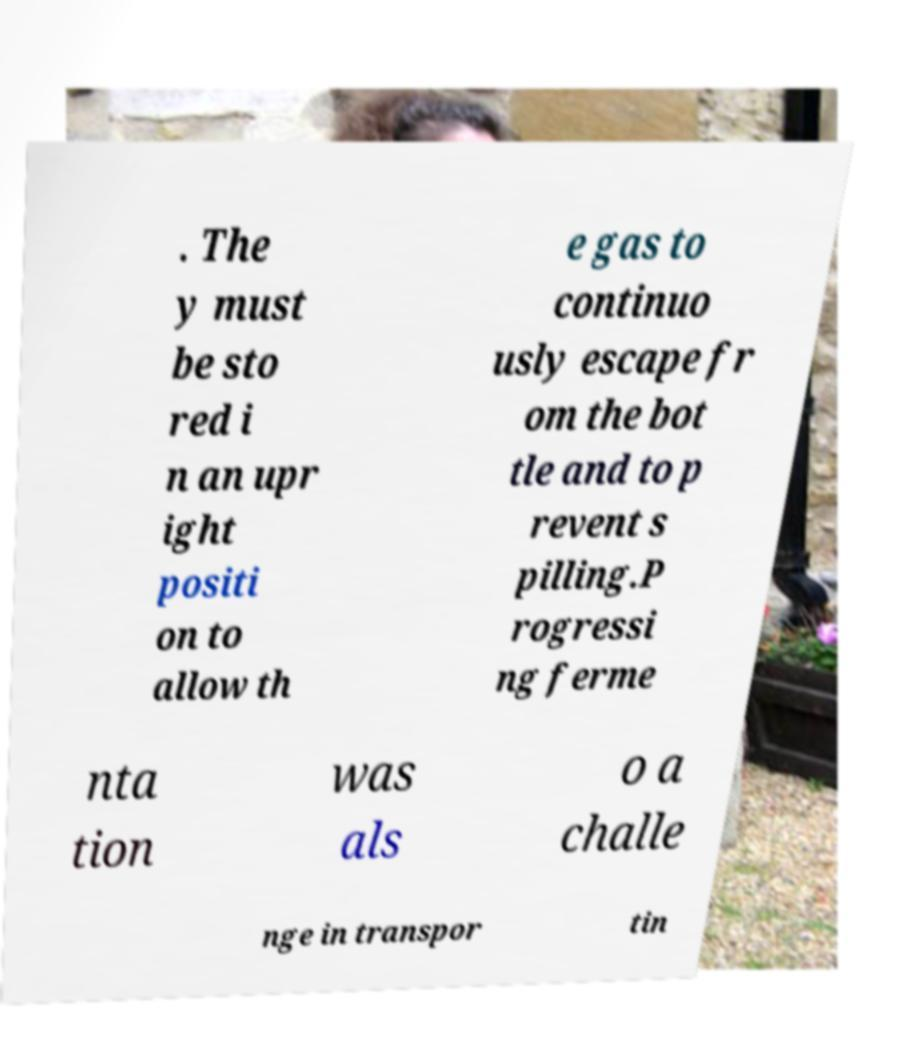What messages or text are displayed in this image? I need them in a readable, typed format. . The y must be sto red i n an upr ight positi on to allow th e gas to continuo usly escape fr om the bot tle and to p revent s pilling.P rogressi ng ferme nta tion was als o a challe nge in transpor tin 